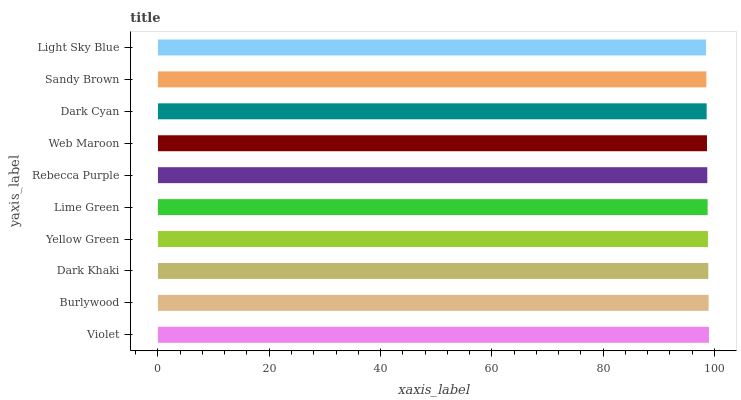Is Light Sky Blue the minimum?
Answer yes or no. Yes. Is Violet the maximum?
Answer yes or no. Yes. Is Burlywood the minimum?
Answer yes or no. No. Is Burlywood the maximum?
Answer yes or no. No. Is Violet greater than Burlywood?
Answer yes or no. Yes. Is Burlywood less than Violet?
Answer yes or no. Yes. Is Burlywood greater than Violet?
Answer yes or no. No. Is Violet less than Burlywood?
Answer yes or no. No. Is Lime Green the high median?
Answer yes or no. Yes. Is Rebecca Purple the low median?
Answer yes or no. Yes. Is Yellow Green the high median?
Answer yes or no. No. Is Light Sky Blue the low median?
Answer yes or no. No. 